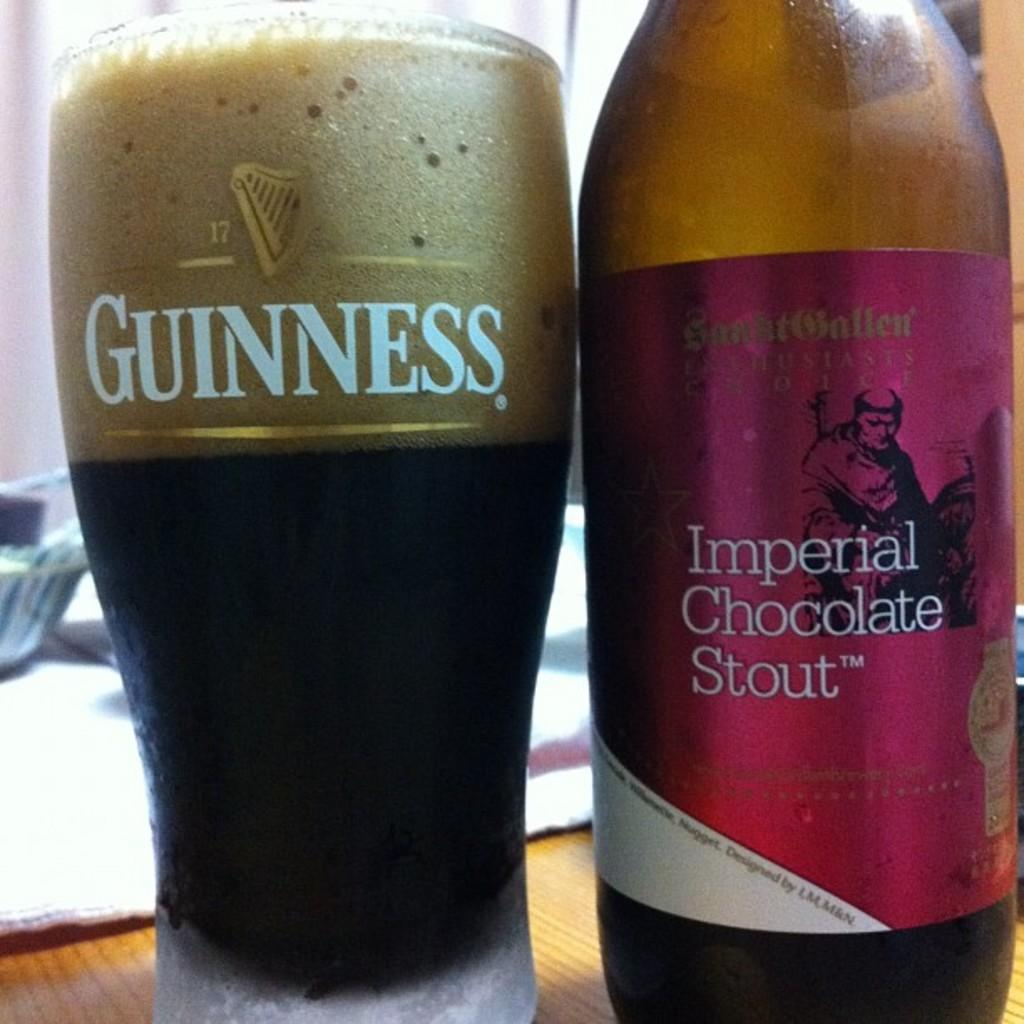<image>
Render a clear and concise summary of the photo. Imperial Chocolate Stout is best served in a Guinness glass. 